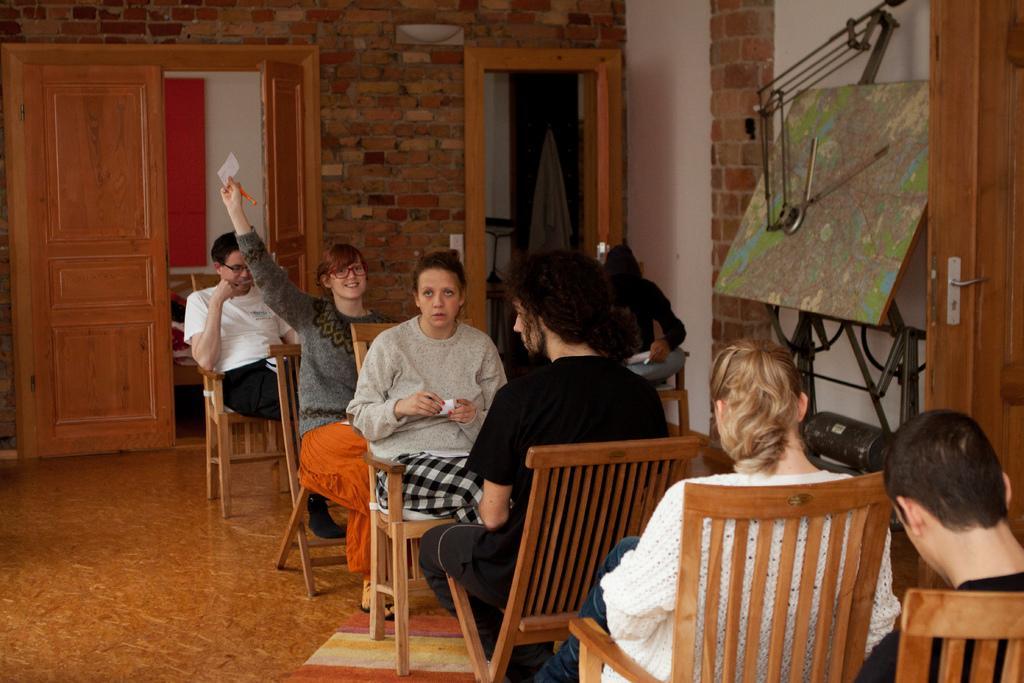In one or two sentences, can you explain what this image depicts? In this picture there are few men and women sit on chairs. It seems to be in a room. On the right side corner there is map with a drafter which held on a stand and the wall is of brick made. There are two doors on right and left side of the room. 